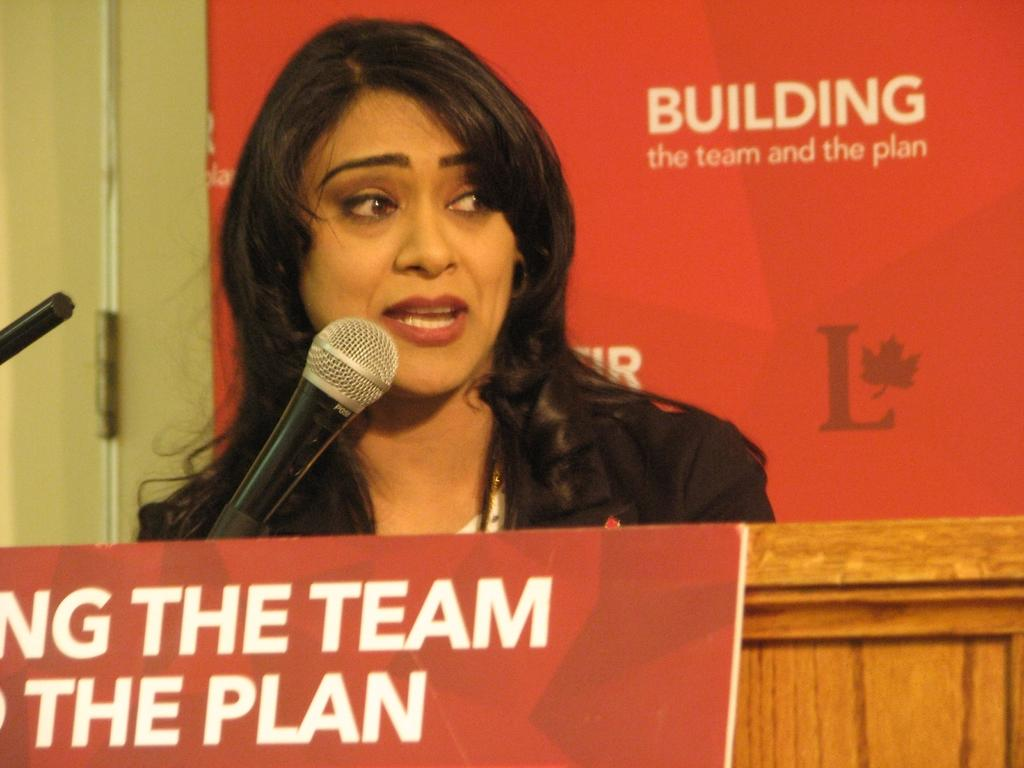Who is the main subject in the image? There is a woman in the image. What is the woman doing in the image? The woman is talking in front of a microphone. What objects are at the bottom of the image? There are wooden pieces and a board at the bottom of the image. What can be seen in the background of the image? There is a wall, a rod, and a banner in the background of the image. What type of bait is being used on the shelf in the image? There is no shelf or bait present in the image. Can you tell me how many teeth are visible on the woman in the image? There is no need to count the woman's teeth in the image, as it is not relevant to the description of the image. 